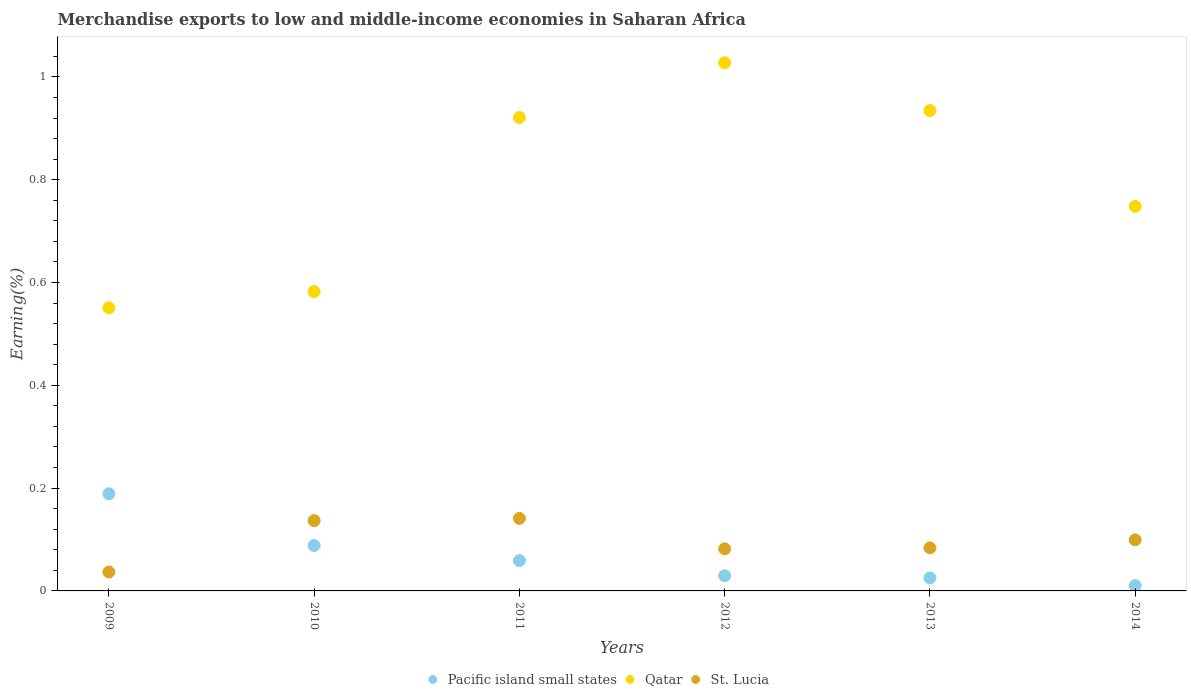What is the percentage of amount earned from merchandise exports in Qatar in 2014?
Make the answer very short. 0.75. Across all years, what is the maximum percentage of amount earned from merchandise exports in Qatar?
Give a very brief answer. 1.03. Across all years, what is the minimum percentage of amount earned from merchandise exports in Qatar?
Give a very brief answer. 0.55. What is the total percentage of amount earned from merchandise exports in St. Lucia in the graph?
Ensure brevity in your answer.  0.58. What is the difference between the percentage of amount earned from merchandise exports in St. Lucia in 2009 and that in 2014?
Provide a short and direct response. -0.06. What is the difference between the percentage of amount earned from merchandise exports in Qatar in 2012 and the percentage of amount earned from merchandise exports in St. Lucia in 2010?
Your answer should be compact. 0.89. What is the average percentage of amount earned from merchandise exports in Pacific island small states per year?
Ensure brevity in your answer.  0.07. In the year 2012, what is the difference between the percentage of amount earned from merchandise exports in Pacific island small states and percentage of amount earned from merchandise exports in St. Lucia?
Your response must be concise. -0.05. What is the ratio of the percentage of amount earned from merchandise exports in St. Lucia in 2009 to that in 2014?
Your response must be concise. 0.37. Is the percentage of amount earned from merchandise exports in Qatar in 2012 less than that in 2013?
Offer a very short reply. No. What is the difference between the highest and the second highest percentage of amount earned from merchandise exports in Qatar?
Offer a very short reply. 0.09. What is the difference between the highest and the lowest percentage of amount earned from merchandise exports in St. Lucia?
Ensure brevity in your answer.  0.1. In how many years, is the percentage of amount earned from merchandise exports in Pacific island small states greater than the average percentage of amount earned from merchandise exports in Pacific island small states taken over all years?
Ensure brevity in your answer.  2. Is the sum of the percentage of amount earned from merchandise exports in St. Lucia in 2010 and 2013 greater than the maximum percentage of amount earned from merchandise exports in Qatar across all years?
Make the answer very short. No. Is the percentage of amount earned from merchandise exports in St. Lucia strictly greater than the percentage of amount earned from merchandise exports in Pacific island small states over the years?
Provide a succinct answer. No. How many dotlines are there?
Provide a short and direct response. 3. What is the difference between two consecutive major ticks on the Y-axis?
Your answer should be compact. 0.2. Are the values on the major ticks of Y-axis written in scientific E-notation?
Ensure brevity in your answer.  No. Does the graph contain grids?
Your answer should be compact. No. Where does the legend appear in the graph?
Your answer should be compact. Bottom center. How many legend labels are there?
Offer a very short reply. 3. How are the legend labels stacked?
Provide a short and direct response. Horizontal. What is the title of the graph?
Provide a short and direct response. Merchandise exports to low and middle-income economies in Saharan Africa. What is the label or title of the Y-axis?
Provide a short and direct response. Earning(%). What is the Earning(%) in Pacific island small states in 2009?
Your response must be concise. 0.19. What is the Earning(%) of Qatar in 2009?
Offer a terse response. 0.55. What is the Earning(%) in St. Lucia in 2009?
Provide a short and direct response. 0.04. What is the Earning(%) in Pacific island small states in 2010?
Make the answer very short. 0.09. What is the Earning(%) of Qatar in 2010?
Keep it short and to the point. 0.58. What is the Earning(%) of St. Lucia in 2010?
Make the answer very short. 0.14. What is the Earning(%) of Pacific island small states in 2011?
Your answer should be very brief. 0.06. What is the Earning(%) of Qatar in 2011?
Give a very brief answer. 0.92. What is the Earning(%) of St. Lucia in 2011?
Ensure brevity in your answer.  0.14. What is the Earning(%) of Pacific island small states in 2012?
Give a very brief answer. 0.03. What is the Earning(%) of Qatar in 2012?
Provide a short and direct response. 1.03. What is the Earning(%) of St. Lucia in 2012?
Your answer should be compact. 0.08. What is the Earning(%) in Pacific island small states in 2013?
Make the answer very short. 0.03. What is the Earning(%) of Qatar in 2013?
Offer a very short reply. 0.93. What is the Earning(%) of St. Lucia in 2013?
Provide a succinct answer. 0.08. What is the Earning(%) in Pacific island small states in 2014?
Give a very brief answer. 0.01. What is the Earning(%) in Qatar in 2014?
Provide a short and direct response. 0.75. What is the Earning(%) in St. Lucia in 2014?
Provide a short and direct response. 0.1. Across all years, what is the maximum Earning(%) of Pacific island small states?
Keep it short and to the point. 0.19. Across all years, what is the maximum Earning(%) of Qatar?
Your response must be concise. 1.03. Across all years, what is the maximum Earning(%) in St. Lucia?
Make the answer very short. 0.14. Across all years, what is the minimum Earning(%) of Pacific island small states?
Your answer should be very brief. 0.01. Across all years, what is the minimum Earning(%) in Qatar?
Give a very brief answer. 0.55. Across all years, what is the minimum Earning(%) in St. Lucia?
Make the answer very short. 0.04. What is the total Earning(%) of Pacific island small states in the graph?
Give a very brief answer. 0.4. What is the total Earning(%) of Qatar in the graph?
Your answer should be compact. 4.76. What is the total Earning(%) in St. Lucia in the graph?
Your answer should be very brief. 0.58. What is the difference between the Earning(%) in Pacific island small states in 2009 and that in 2010?
Offer a very short reply. 0.1. What is the difference between the Earning(%) of Qatar in 2009 and that in 2010?
Ensure brevity in your answer.  -0.03. What is the difference between the Earning(%) in St. Lucia in 2009 and that in 2010?
Make the answer very short. -0.1. What is the difference between the Earning(%) of Pacific island small states in 2009 and that in 2011?
Keep it short and to the point. 0.13. What is the difference between the Earning(%) in Qatar in 2009 and that in 2011?
Provide a short and direct response. -0.37. What is the difference between the Earning(%) of St. Lucia in 2009 and that in 2011?
Your answer should be very brief. -0.1. What is the difference between the Earning(%) in Pacific island small states in 2009 and that in 2012?
Your answer should be very brief. 0.16. What is the difference between the Earning(%) in Qatar in 2009 and that in 2012?
Offer a very short reply. -0.48. What is the difference between the Earning(%) in St. Lucia in 2009 and that in 2012?
Offer a very short reply. -0.05. What is the difference between the Earning(%) in Pacific island small states in 2009 and that in 2013?
Your answer should be very brief. 0.16. What is the difference between the Earning(%) in Qatar in 2009 and that in 2013?
Keep it short and to the point. -0.38. What is the difference between the Earning(%) in St. Lucia in 2009 and that in 2013?
Your response must be concise. -0.05. What is the difference between the Earning(%) in Pacific island small states in 2009 and that in 2014?
Make the answer very short. 0.18. What is the difference between the Earning(%) of Qatar in 2009 and that in 2014?
Provide a succinct answer. -0.2. What is the difference between the Earning(%) of St. Lucia in 2009 and that in 2014?
Offer a very short reply. -0.06. What is the difference between the Earning(%) of Pacific island small states in 2010 and that in 2011?
Your answer should be very brief. 0.03. What is the difference between the Earning(%) of Qatar in 2010 and that in 2011?
Your answer should be compact. -0.34. What is the difference between the Earning(%) of St. Lucia in 2010 and that in 2011?
Offer a very short reply. -0. What is the difference between the Earning(%) of Pacific island small states in 2010 and that in 2012?
Offer a very short reply. 0.06. What is the difference between the Earning(%) in Qatar in 2010 and that in 2012?
Make the answer very short. -0.45. What is the difference between the Earning(%) of St. Lucia in 2010 and that in 2012?
Offer a terse response. 0.05. What is the difference between the Earning(%) of Pacific island small states in 2010 and that in 2013?
Provide a succinct answer. 0.06. What is the difference between the Earning(%) of Qatar in 2010 and that in 2013?
Ensure brevity in your answer.  -0.35. What is the difference between the Earning(%) in St. Lucia in 2010 and that in 2013?
Provide a succinct answer. 0.05. What is the difference between the Earning(%) of Pacific island small states in 2010 and that in 2014?
Offer a terse response. 0.08. What is the difference between the Earning(%) of Qatar in 2010 and that in 2014?
Your response must be concise. -0.17. What is the difference between the Earning(%) in St. Lucia in 2010 and that in 2014?
Provide a succinct answer. 0.04. What is the difference between the Earning(%) of Pacific island small states in 2011 and that in 2012?
Provide a short and direct response. 0.03. What is the difference between the Earning(%) in Qatar in 2011 and that in 2012?
Keep it short and to the point. -0.11. What is the difference between the Earning(%) of St. Lucia in 2011 and that in 2012?
Keep it short and to the point. 0.06. What is the difference between the Earning(%) of Pacific island small states in 2011 and that in 2013?
Keep it short and to the point. 0.03. What is the difference between the Earning(%) in Qatar in 2011 and that in 2013?
Provide a succinct answer. -0.01. What is the difference between the Earning(%) of St. Lucia in 2011 and that in 2013?
Give a very brief answer. 0.06. What is the difference between the Earning(%) in Pacific island small states in 2011 and that in 2014?
Offer a very short reply. 0.05. What is the difference between the Earning(%) in Qatar in 2011 and that in 2014?
Your answer should be very brief. 0.17. What is the difference between the Earning(%) in St. Lucia in 2011 and that in 2014?
Offer a terse response. 0.04. What is the difference between the Earning(%) in Pacific island small states in 2012 and that in 2013?
Your answer should be compact. 0. What is the difference between the Earning(%) of Qatar in 2012 and that in 2013?
Your response must be concise. 0.09. What is the difference between the Earning(%) in St. Lucia in 2012 and that in 2013?
Offer a terse response. -0. What is the difference between the Earning(%) in Pacific island small states in 2012 and that in 2014?
Your response must be concise. 0.02. What is the difference between the Earning(%) of Qatar in 2012 and that in 2014?
Keep it short and to the point. 0.28. What is the difference between the Earning(%) of St. Lucia in 2012 and that in 2014?
Provide a succinct answer. -0.02. What is the difference between the Earning(%) of Pacific island small states in 2013 and that in 2014?
Keep it short and to the point. 0.02. What is the difference between the Earning(%) of Qatar in 2013 and that in 2014?
Provide a succinct answer. 0.19. What is the difference between the Earning(%) in St. Lucia in 2013 and that in 2014?
Provide a succinct answer. -0.02. What is the difference between the Earning(%) of Pacific island small states in 2009 and the Earning(%) of Qatar in 2010?
Provide a succinct answer. -0.39. What is the difference between the Earning(%) in Pacific island small states in 2009 and the Earning(%) in St. Lucia in 2010?
Give a very brief answer. 0.05. What is the difference between the Earning(%) of Qatar in 2009 and the Earning(%) of St. Lucia in 2010?
Your answer should be very brief. 0.41. What is the difference between the Earning(%) in Pacific island small states in 2009 and the Earning(%) in Qatar in 2011?
Provide a succinct answer. -0.73. What is the difference between the Earning(%) in Pacific island small states in 2009 and the Earning(%) in St. Lucia in 2011?
Ensure brevity in your answer.  0.05. What is the difference between the Earning(%) in Qatar in 2009 and the Earning(%) in St. Lucia in 2011?
Offer a very short reply. 0.41. What is the difference between the Earning(%) in Pacific island small states in 2009 and the Earning(%) in Qatar in 2012?
Keep it short and to the point. -0.84. What is the difference between the Earning(%) in Pacific island small states in 2009 and the Earning(%) in St. Lucia in 2012?
Keep it short and to the point. 0.11. What is the difference between the Earning(%) in Qatar in 2009 and the Earning(%) in St. Lucia in 2012?
Provide a succinct answer. 0.47. What is the difference between the Earning(%) in Pacific island small states in 2009 and the Earning(%) in Qatar in 2013?
Offer a very short reply. -0.75. What is the difference between the Earning(%) in Pacific island small states in 2009 and the Earning(%) in St. Lucia in 2013?
Your answer should be very brief. 0.11. What is the difference between the Earning(%) in Qatar in 2009 and the Earning(%) in St. Lucia in 2013?
Give a very brief answer. 0.47. What is the difference between the Earning(%) of Pacific island small states in 2009 and the Earning(%) of Qatar in 2014?
Keep it short and to the point. -0.56. What is the difference between the Earning(%) of Pacific island small states in 2009 and the Earning(%) of St. Lucia in 2014?
Your answer should be very brief. 0.09. What is the difference between the Earning(%) of Qatar in 2009 and the Earning(%) of St. Lucia in 2014?
Offer a terse response. 0.45. What is the difference between the Earning(%) of Pacific island small states in 2010 and the Earning(%) of Qatar in 2011?
Keep it short and to the point. -0.83. What is the difference between the Earning(%) of Pacific island small states in 2010 and the Earning(%) of St. Lucia in 2011?
Ensure brevity in your answer.  -0.05. What is the difference between the Earning(%) in Qatar in 2010 and the Earning(%) in St. Lucia in 2011?
Ensure brevity in your answer.  0.44. What is the difference between the Earning(%) in Pacific island small states in 2010 and the Earning(%) in Qatar in 2012?
Make the answer very short. -0.94. What is the difference between the Earning(%) in Pacific island small states in 2010 and the Earning(%) in St. Lucia in 2012?
Provide a short and direct response. 0.01. What is the difference between the Earning(%) in Qatar in 2010 and the Earning(%) in St. Lucia in 2012?
Provide a succinct answer. 0.5. What is the difference between the Earning(%) of Pacific island small states in 2010 and the Earning(%) of Qatar in 2013?
Make the answer very short. -0.85. What is the difference between the Earning(%) in Pacific island small states in 2010 and the Earning(%) in St. Lucia in 2013?
Keep it short and to the point. 0. What is the difference between the Earning(%) of Qatar in 2010 and the Earning(%) of St. Lucia in 2013?
Offer a very short reply. 0.5. What is the difference between the Earning(%) of Pacific island small states in 2010 and the Earning(%) of Qatar in 2014?
Keep it short and to the point. -0.66. What is the difference between the Earning(%) in Pacific island small states in 2010 and the Earning(%) in St. Lucia in 2014?
Offer a very short reply. -0.01. What is the difference between the Earning(%) of Qatar in 2010 and the Earning(%) of St. Lucia in 2014?
Offer a very short reply. 0.48. What is the difference between the Earning(%) of Pacific island small states in 2011 and the Earning(%) of Qatar in 2012?
Your answer should be compact. -0.97. What is the difference between the Earning(%) of Pacific island small states in 2011 and the Earning(%) of St. Lucia in 2012?
Your answer should be very brief. -0.02. What is the difference between the Earning(%) in Qatar in 2011 and the Earning(%) in St. Lucia in 2012?
Provide a succinct answer. 0.84. What is the difference between the Earning(%) of Pacific island small states in 2011 and the Earning(%) of Qatar in 2013?
Make the answer very short. -0.88. What is the difference between the Earning(%) of Pacific island small states in 2011 and the Earning(%) of St. Lucia in 2013?
Make the answer very short. -0.02. What is the difference between the Earning(%) in Qatar in 2011 and the Earning(%) in St. Lucia in 2013?
Offer a very short reply. 0.84. What is the difference between the Earning(%) of Pacific island small states in 2011 and the Earning(%) of Qatar in 2014?
Offer a very short reply. -0.69. What is the difference between the Earning(%) in Pacific island small states in 2011 and the Earning(%) in St. Lucia in 2014?
Provide a short and direct response. -0.04. What is the difference between the Earning(%) of Qatar in 2011 and the Earning(%) of St. Lucia in 2014?
Provide a succinct answer. 0.82. What is the difference between the Earning(%) of Pacific island small states in 2012 and the Earning(%) of Qatar in 2013?
Ensure brevity in your answer.  -0.91. What is the difference between the Earning(%) of Pacific island small states in 2012 and the Earning(%) of St. Lucia in 2013?
Offer a terse response. -0.05. What is the difference between the Earning(%) of Qatar in 2012 and the Earning(%) of St. Lucia in 2013?
Offer a very short reply. 0.94. What is the difference between the Earning(%) of Pacific island small states in 2012 and the Earning(%) of Qatar in 2014?
Offer a terse response. -0.72. What is the difference between the Earning(%) of Pacific island small states in 2012 and the Earning(%) of St. Lucia in 2014?
Make the answer very short. -0.07. What is the difference between the Earning(%) of Qatar in 2012 and the Earning(%) of St. Lucia in 2014?
Your answer should be compact. 0.93. What is the difference between the Earning(%) of Pacific island small states in 2013 and the Earning(%) of Qatar in 2014?
Make the answer very short. -0.72. What is the difference between the Earning(%) in Pacific island small states in 2013 and the Earning(%) in St. Lucia in 2014?
Offer a very short reply. -0.07. What is the difference between the Earning(%) of Qatar in 2013 and the Earning(%) of St. Lucia in 2014?
Give a very brief answer. 0.84. What is the average Earning(%) in Pacific island small states per year?
Offer a terse response. 0.07. What is the average Earning(%) in Qatar per year?
Give a very brief answer. 0.79. What is the average Earning(%) in St. Lucia per year?
Your response must be concise. 0.1. In the year 2009, what is the difference between the Earning(%) of Pacific island small states and Earning(%) of Qatar?
Your answer should be very brief. -0.36. In the year 2009, what is the difference between the Earning(%) in Pacific island small states and Earning(%) in St. Lucia?
Your answer should be compact. 0.15. In the year 2009, what is the difference between the Earning(%) of Qatar and Earning(%) of St. Lucia?
Your answer should be very brief. 0.51. In the year 2010, what is the difference between the Earning(%) of Pacific island small states and Earning(%) of Qatar?
Offer a terse response. -0.49. In the year 2010, what is the difference between the Earning(%) in Pacific island small states and Earning(%) in St. Lucia?
Provide a succinct answer. -0.05. In the year 2010, what is the difference between the Earning(%) in Qatar and Earning(%) in St. Lucia?
Your answer should be very brief. 0.45. In the year 2011, what is the difference between the Earning(%) in Pacific island small states and Earning(%) in Qatar?
Your answer should be compact. -0.86. In the year 2011, what is the difference between the Earning(%) in Pacific island small states and Earning(%) in St. Lucia?
Your response must be concise. -0.08. In the year 2011, what is the difference between the Earning(%) in Qatar and Earning(%) in St. Lucia?
Offer a very short reply. 0.78. In the year 2012, what is the difference between the Earning(%) in Pacific island small states and Earning(%) in Qatar?
Offer a very short reply. -1. In the year 2012, what is the difference between the Earning(%) in Pacific island small states and Earning(%) in St. Lucia?
Make the answer very short. -0.05. In the year 2012, what is the difference between the Earning(%) of Qatar and Earning(%) of St. Lucia?
Your answer should be compact. 0.95. In the year 2013, what is the difference between the Earning(%) of Pacific island small states and Earning(%) of Qatar?
Your answer should be very brief. -0.91. In the year 2013, what is the difference between the Earning(%) in Pacific island small states and Earning(%) in St. Lucia?
Make the answer very short. -0.06. In the year 2013, what is the difference between the Earning(%) in Qatar and Earning(%) in St. Lucia?
Offer a terse response. 0.85. In the year 2014, what is the difference between the Earning(%) in Pacific island small states and Earning(%) in Qatar?
Give a very brief answer. -0.74. In the year 2014, what is the difference between the Earning(%) of Pacific island small states and Earning(%) of St. Lucia?
Make the answer very short. -0.09. In the year 2014, what is the difference between the Earning(%) of Qatar and Earning(%) of St. Lucia?
Offer a terse response. 0.65. What is the ratio of the Earning(%) in Pacific island small states in 2009 to that in 2010?
Your answer should be very brief. 2.14. What is the ratio of the Earning(%) in Qatar in 2009 to that in 2010?
Provide a succinct answer. 0.95. What is the ratio of the Earning(%) of St. Lucia in 2009 to that in 2010?
Make the answer very short. 0.27. What is the ratio of the Earning(%) in Pacific island small states in 2009 to that in 2011?
Give a very brief answer. 3.2. What is the ratio of the Earning(%) of Qatar in 2009 to that in 2011?
Offer a very short reply. 0.6. What is the ratio of the Earning(%) of St. Lucia in 2009 to that in 2011?
Make the answer very short. 0.26. What is the ratio of the Earning(%) in Pacific island small states in 2009 to that in 2012?
Provide a succinct answer. 6.4. What is the ratio of the Earning(%) in Qatar in 2009 to that in 2012?
Your response must be concise. 0.54. What is the ratio of the Earning(%) in St. Lucia in 2009 to that in 2012?
Offer a very short reply. 0.45. What is the ratio of the Earning(%) in Pacific island small states in 2009 to that in 2013?
Ensure brevity in your answer.  7.46. What is the ratio of the Earning(%) in Qatar in 2009 to that in 2013?
Your response must be concise. 0.59. What is the ratio of the Earning(%) in St. Lucia in 2009 to that in 2013?
Your answer should be very brief. 0.44. What is the ratio of the Earning(%) of Pacific island small states in 2009 to that in 2014?
Give a very brief answer. 18.44. What is the ratio of the Earning(%) in Qatar in 2009 to that in 2014?
Your answer should be compact. 0.74. What is the ratio of the Earning(%) of St. Lucia in 2009 to that in 2014?
Provide a short and direct response. 0.37. What is the ratio of the Earning(%) of Pacific island small states in 2010 to that in 2011?
Provide a succinct answer. 1.5. What is the ratio of the Earning(%) in Qatar in 2010 to that in 2011?
Provide a succinct answer. 0.63. What is the ratio of the Earning(%) of St. Lucia in 2010 to that in 2011?
Ensure brevity in your answer.  0.97. What is the ratio of the Earning(%) in Pacific island small states in 2010 to that in 2012?
Provide a short and direct response. 2.99. What is the ratio of the Earning(%) in Qatar in 2010 to that in 2012?
Your answer should be compact. 0.57. What is the ratio of the Earning(%) in St. Lucia in 2010 to that in 2012?
Offer a very short reply. 1.67. What is the ratio of the Earning(%) in Pacific island small states in 2010 to that in 2013?
Provide a short and direct response. 3.49. What is the ratio of the Earning(%) in Qatar in 2010 to that in 2013?
Give a very brief answer. 0.62. What is the ratio of the Earning(%) in St. Lucia in 2010 to that in 2013?
Provide a succinct answer. 1.63. What is the ratio of the Earning(%) in Pacific island small states in 2010 to that in 2014?
Ensure brevity in your answer.  8.62. What is the ratio of the Earning(%) in Qatar in 2010 to that in 2014?
Provide a succinct answer. 0.78. What is the ratio of the Earning(%) in St. Lucia in 2010 to that in 2014?
Offer a very short reply. 1.38. What is the ratio of the Earning(%) of Pacific island small states in 2011 to that in 2012?
Make the answer very short. 2. What is the ratio of the Earning(%) in Qatar in 2011 to that in 2012?
Your response must be concise. 0.9. What is the ratio of the Earning(%) of St. Lucia in 2011 to that in 2012?
Offer a terse response. 1.72. What is the ratio of the Earning(%) in Pacific island small states in 2011 to that in 2013?
Your answer should be compact. 2.33. What is the ratio of the Earning(%) in Qatar in 2011 to that in 2013?
Keep it short and to the point. 0.99. What is the ratio of the Earning(%) in St. Lucia in 2011 to that in 2013?
Your response must be concise. 1.69. What is the ratio of the Earning(%) of Pacific island small states in 2011 to that in 2014?
Provide a short and direct response. 5.76. What is the ratio of the Earning(%) in Qatar in 2011 to that in 2014?
Provide a short and direct response. 1.23. What is the ratio of the Earning(%) of St. Lucia in 2011 to that in 2014?
Your response must be concise. 1.42. What is the ratio of the Earning(%) of Pacific island small states in 2012 to that in 2013?
Keep it short and to the point. 1.16. What is the ratio of the Earning(%) in Qatar in 2012 to that in 2013?
Provide a short and direct response. 1.1. What is the ratio of the Earning(%) of St. Lucia in 2012 to that in 2013?
Offer a very short reply. 0.98. What is the ratio of the Earning(%) of Pacific island small states in 2012 to that in 2014?
Your response must be concise. 2.88. What is the ratio of the Earning(%) in Qatar in 2012 to that in 2014?
Keep it short and to the point. 1.37. What is the ratio of the Earning(%) in St. Lucia in 2012 to that in 2014?
Your response must be concise. 0.82. What is the ratio of the Earning(%) in Pacific island small states in 2013 to that in 2014?
Keep it short and to the point. 2.47. What is the ratio of the Earning(%) of Qatar in 2013 to that in 2014?
Your answer should be very brief. 1.25. What is the ratio of the Earning(%) in St. Lucia in 2013 to that in 2014?
Give a very brief answer. 0.84. What is the difference between the highest and the second highest Earning(%) of Pacific island small states?
Your answer should be compact. 0.1. What is the difference between the highest and the second highest Earning(%) of Qatar?
Ensure brevity in your answer.  0.09. What is the difference between the highest and the second highest Earning(%) in St. Lucia?
Provide a succinct answer. 0. What is the difference between the highest and the lowest Earning(%) in Pacific island small states?
Provide a succinct answer. 0.18. What is the difference between the highest and the lowest Earning(%) in Qatar?
Make the answer very short. 0.48. What is the difference between the highest and the lowest Earning(%) of St. Lucia?
Give a very brief answer. 0.1. 